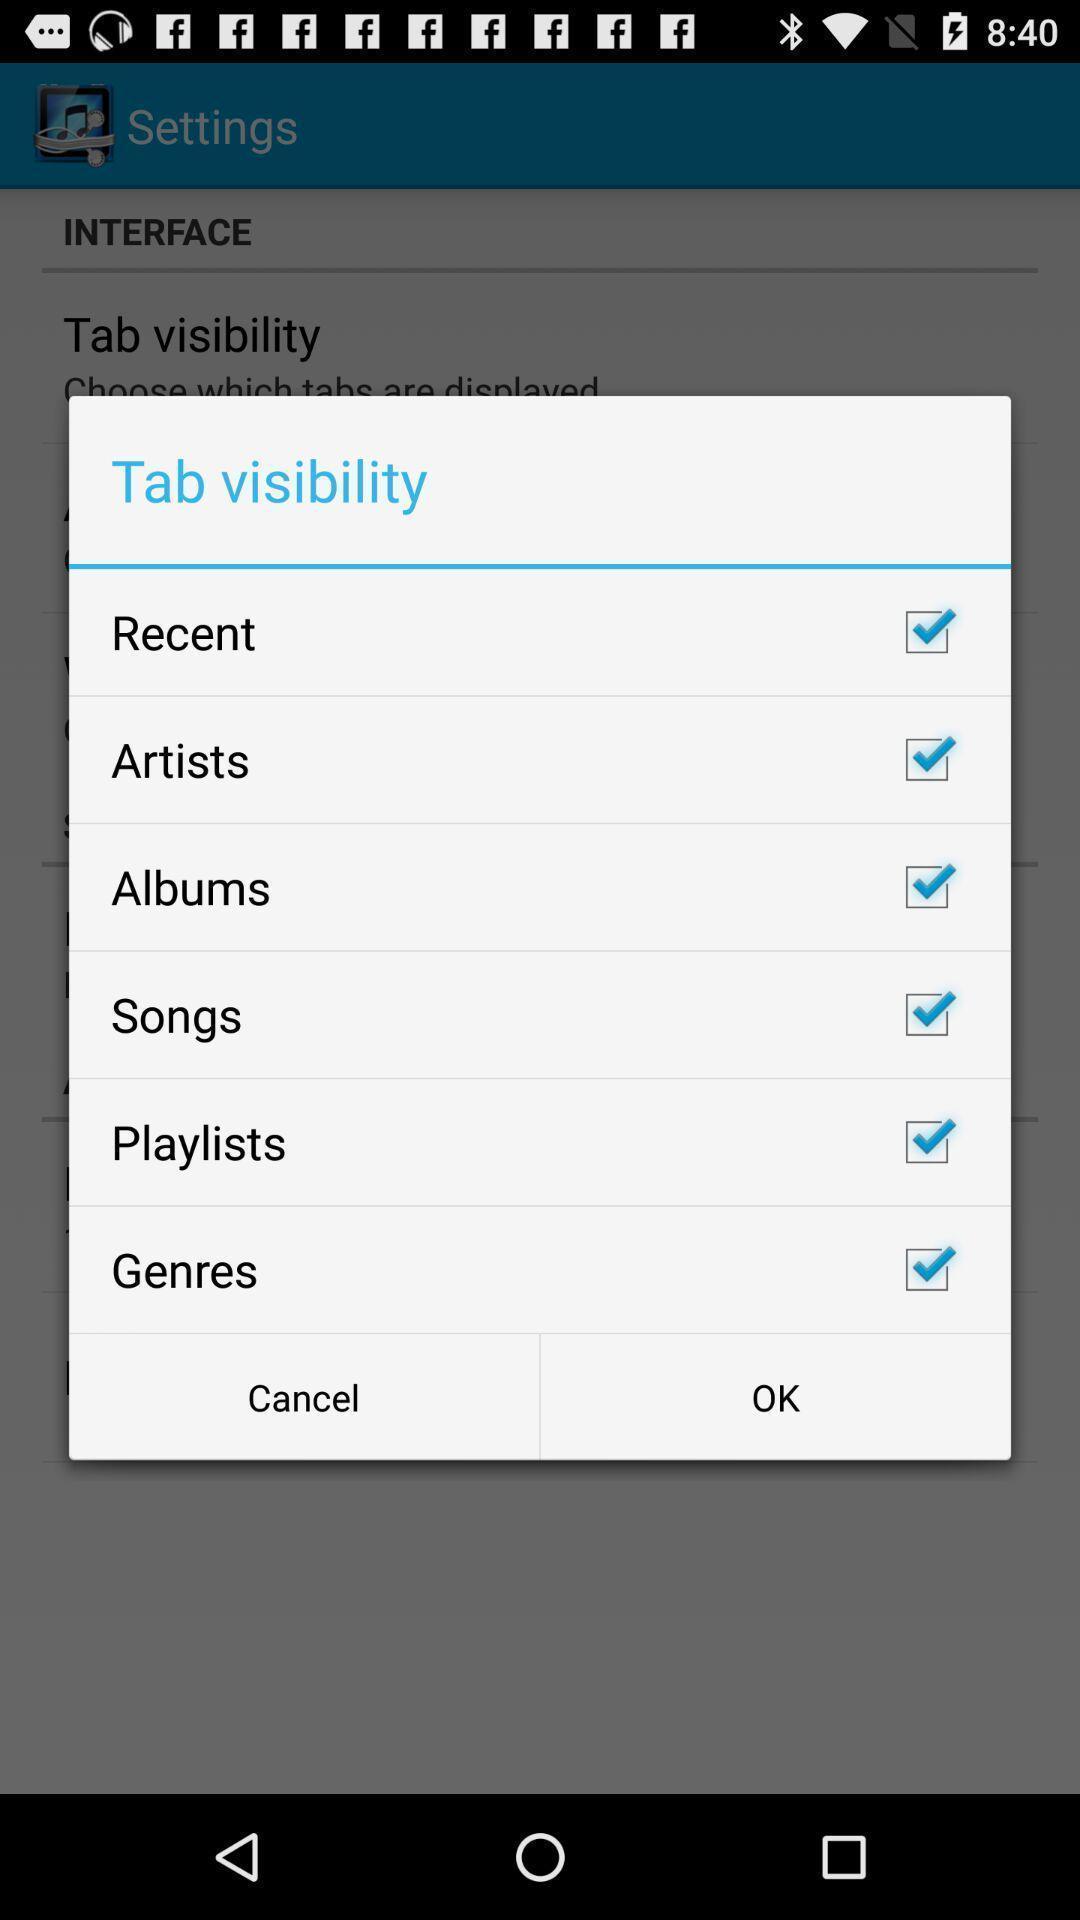Describe the content in this image. Pop up window with different options of a music app. 